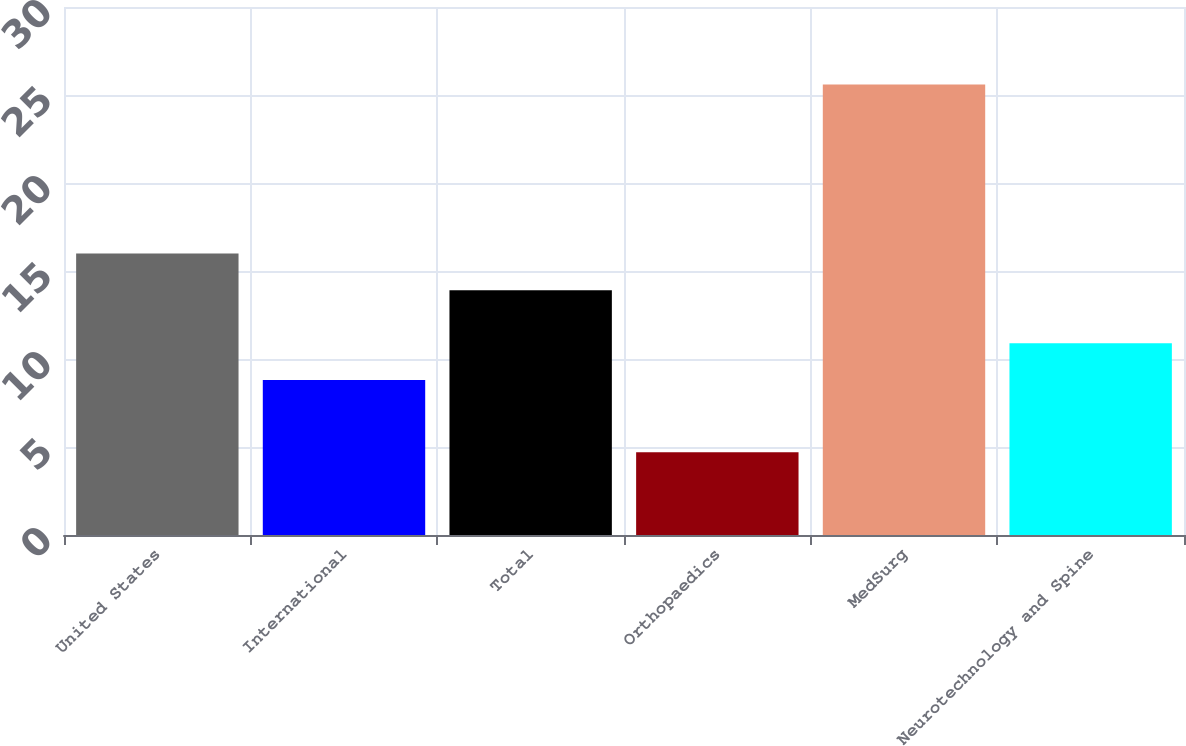<chart> <loc_0><loc_0><loc_500><loc_500><bar_chart><fcel>United States<fcel>International<fcel>Total<fcel>Orthopaedics<fcel>MedSurg<fcel>Neurotechnology and Spine<nl><fcel>15.99<fcel>8.8<fcel>13.9<fcel>4.7<fcel>25.6<fcel>10.89<nl></chart> 